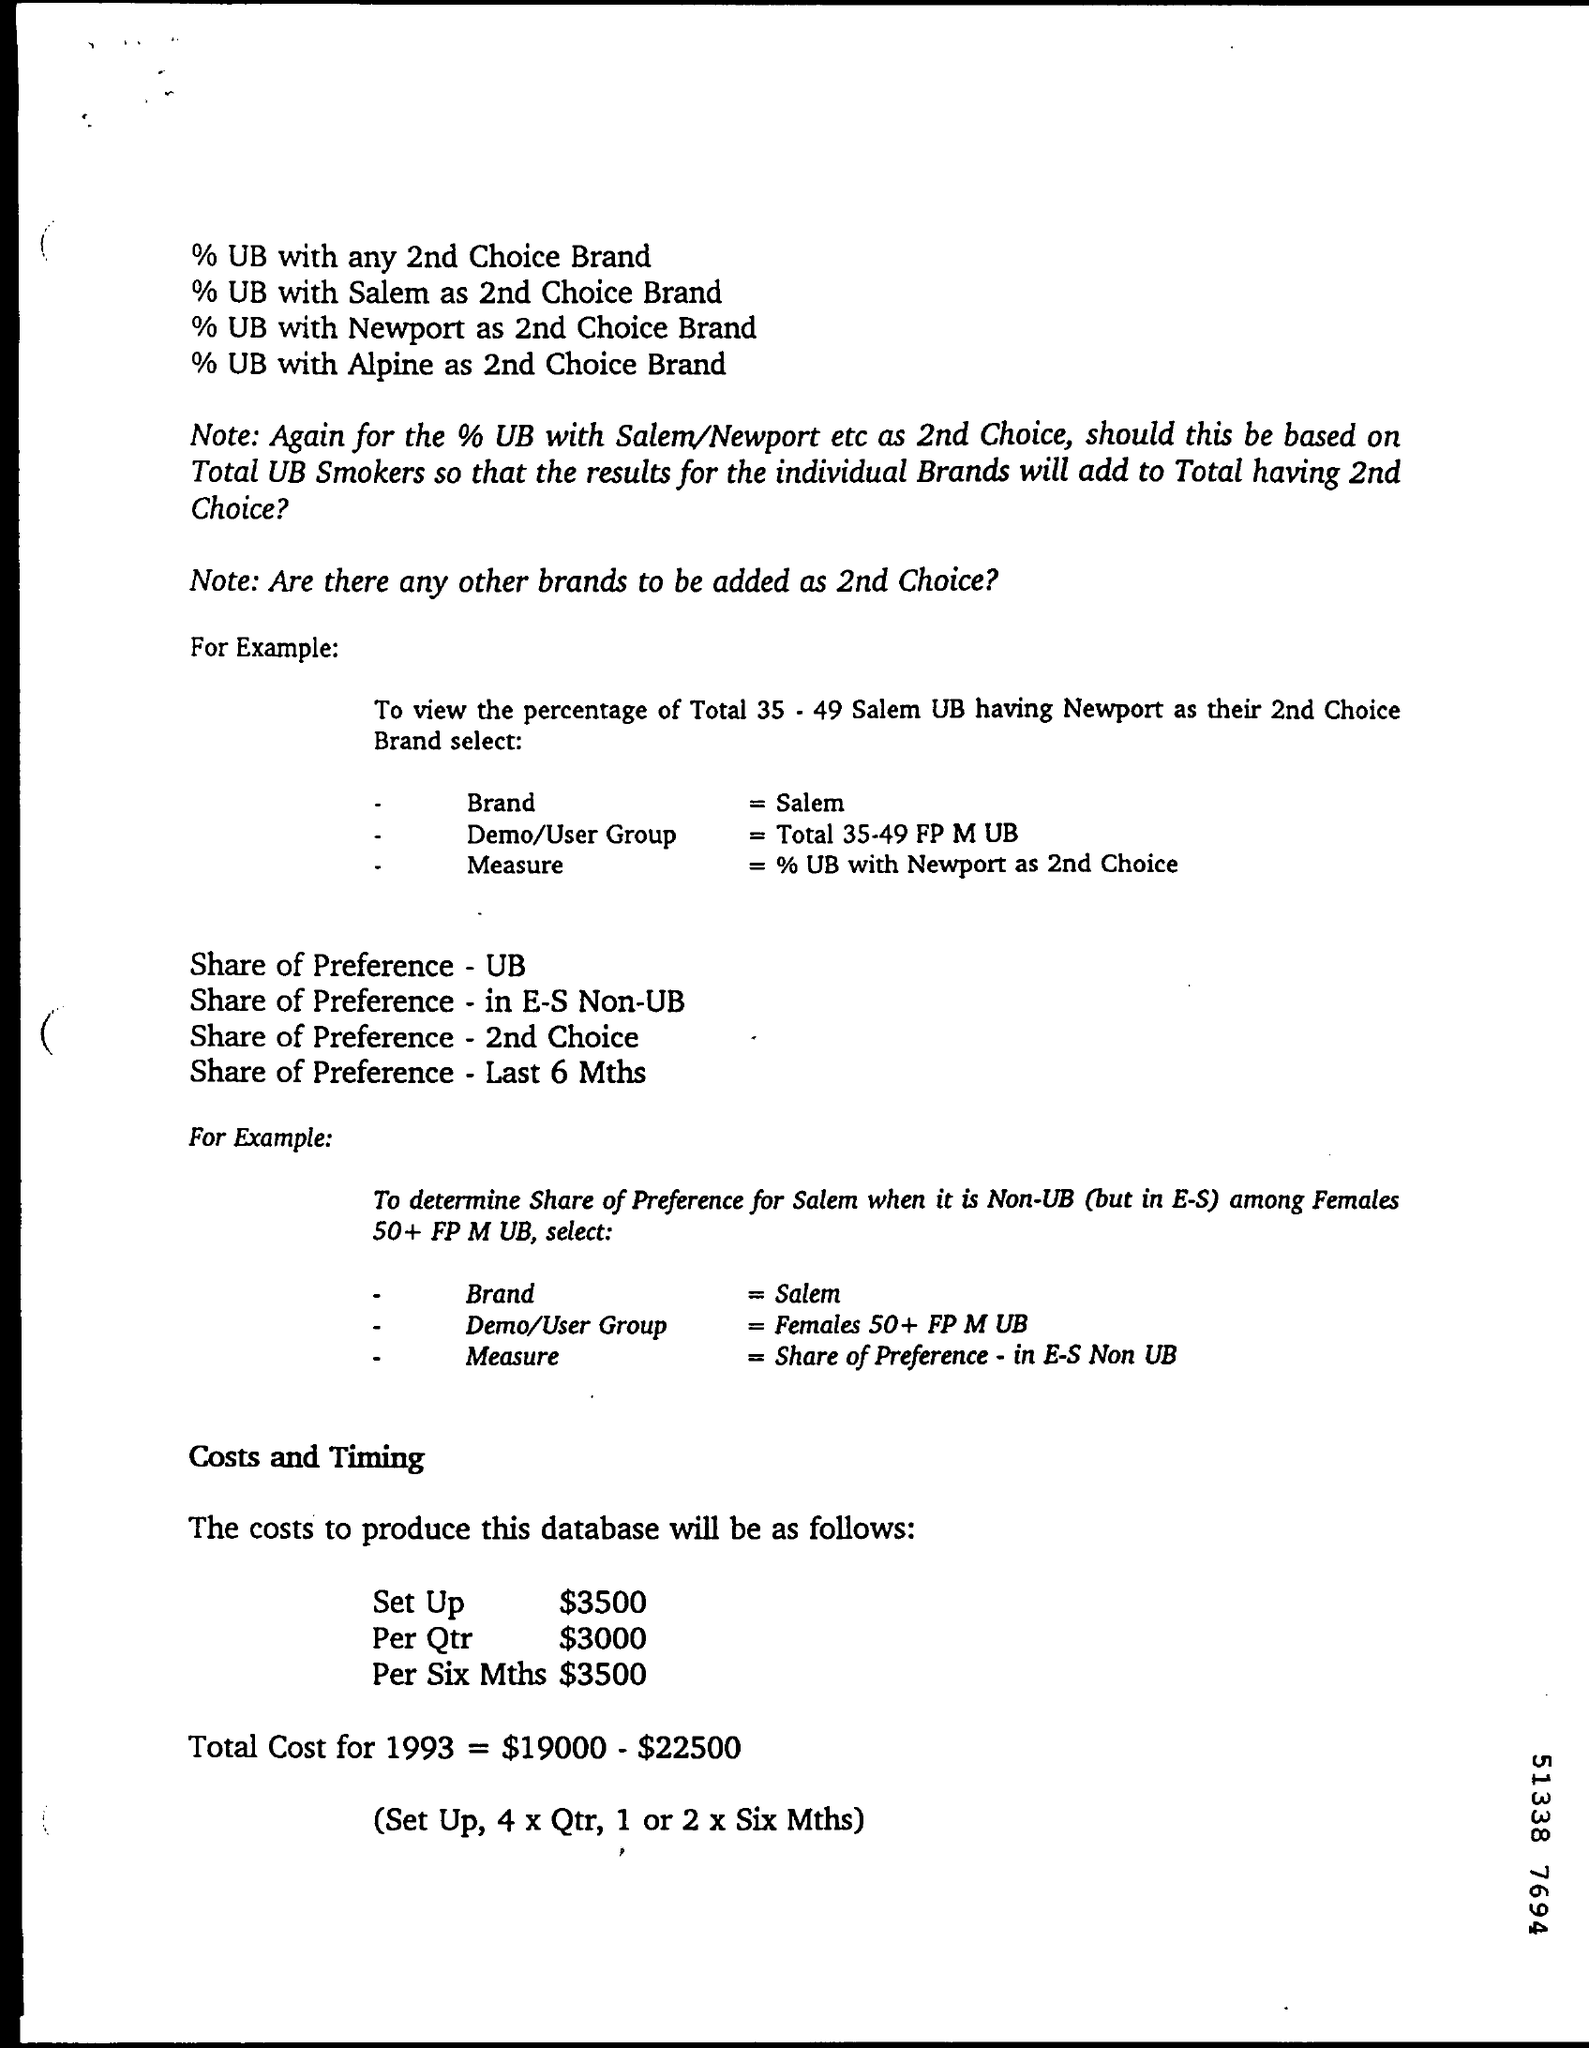Specify some key components in this picture. The set-up cost for the project is $3,500. The total cost for 1993 was $19,000, excluding expenses of $22,500. 